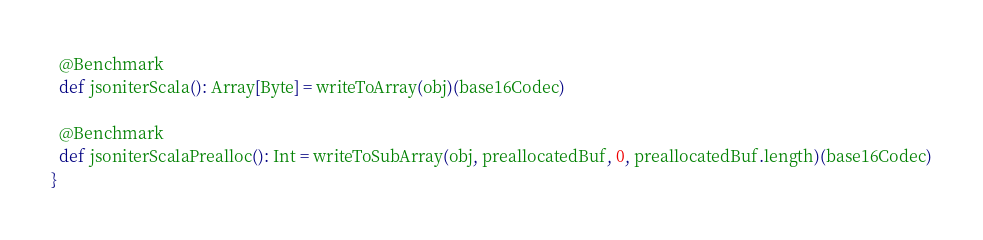<code> <loc_0><loc_0><loc_500><loc_500><_Scala_>
  @Benchmark
  def jsoniterScala(): Array[Byte] = writeToArray(obj)(base16Codec)

  @Benchmark
  def jsoniterScalaPrealloc(): Int = writeToSubArray(obj, preallocatedBuf, 0, preallocatedBuf.length)(base16Codec)
}</code> 